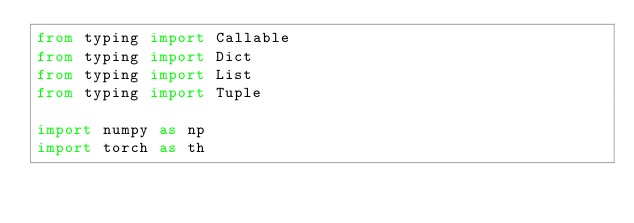<code> <loc_0><loc_0><loc_500><loc_500><_Python_>from typing import Callable
from typing import Dict
from typing import List
from typing import Tuple

import numpy as np
import torch as th
</code> 